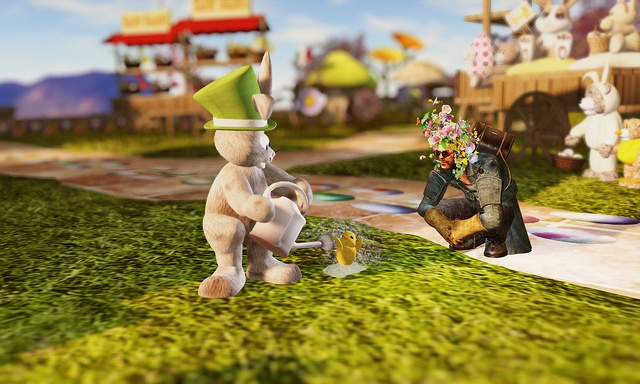Describe the objects in this image and their specific colors. I can see people in lightblue, black, olive, gray, and tan tones, teddy bear in lightblue, beige, and tan tones, and bowl in lightblue, maroon, black, and brown tones in this image. 